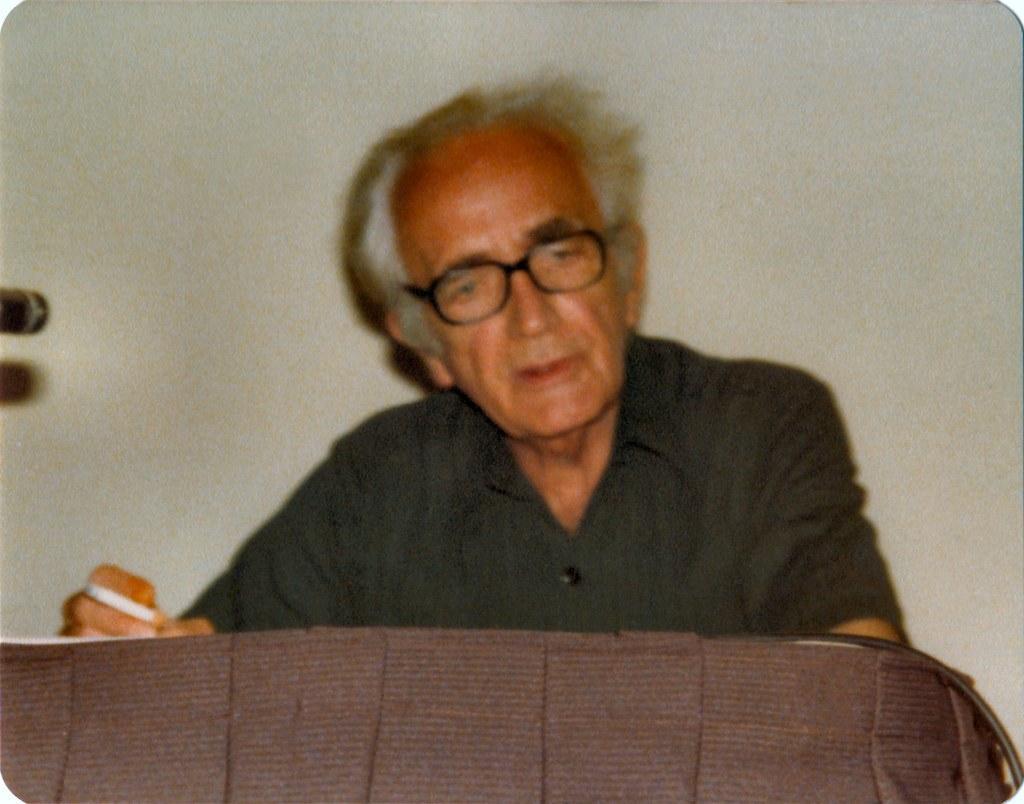Please provide a concise description of this image. In this picture I can see a man and he is holding a cigarette in his hand and looks like a table and I can see a wall in the background. 